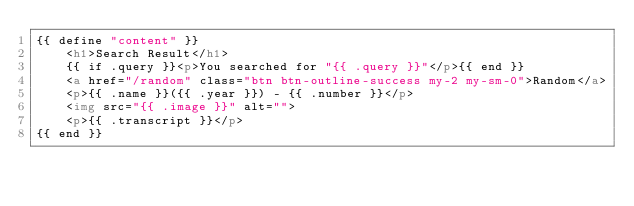<code> <loc_0><loc_0><loc_500><loc_500><_HTML_>{{ define "content" }}
    <h1>Search Result</h1>
    {{ if .query }}<p>You searched for "{{ .query }}"</p>{{ end }}
    <a href="/random" class="btn btn-outline-success my-2 my-sm-0">Random</a>
    <p>{{ .name }}({{ .year }}) - {{ .number }}</p>
    <img src="{{ .image }}" alt="">
    <p>{{ .transcript }}</p>
{{ end }}</code> 